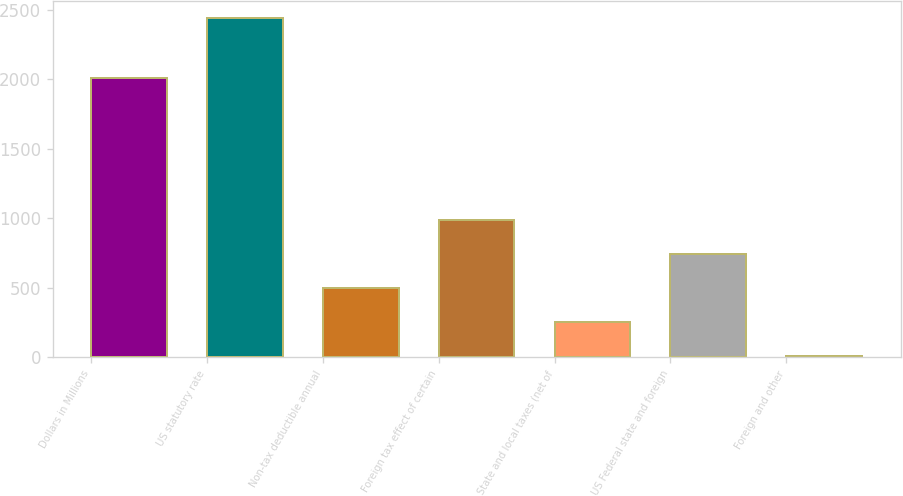Convert chart to OTSL. <chart><loc_0><loc_0><loc_500><loc_500><bar_chart><fcel>Dollars in Millions<fcel>US statutory rate<fcel>Non-tax deductible annual<fcel>Foreign tax effect of certain<fcel>State and local taxes (net of<fcel>US Federal state and foreign<fcel>Foreign and other<nl><fcel>2011<fcel>2443<fcel>498.2<fcel>984.4<fcel>255.1<fcel>741.3<fcel>12<nl></chart> 